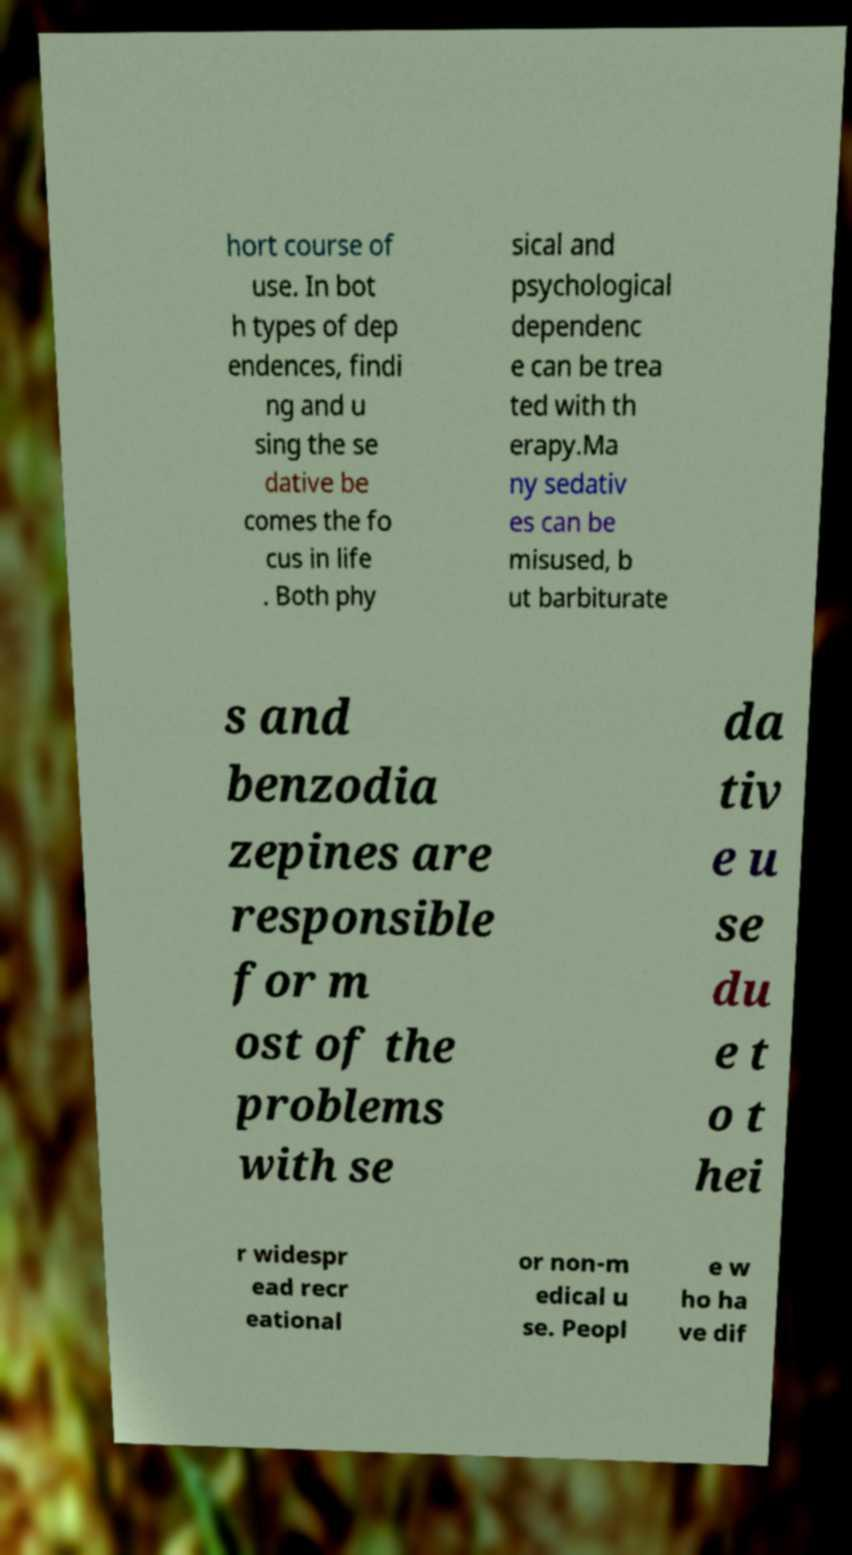Please read and relay the text visible in this image. What does it say? hort course of use. In bot h types of dep endences, findi ng and u sing the se dative be comes the fo cus in life . Both phy sical and psychological dependenc e can be trea ted with th erapy.Ma ny sedativ es can be misused, b ut barbiturate s and benzodia zepines are responsible for m ost of the problems with se da tiv e u se du e t o t hei r widespr ead recr eational or non-m edical u se. Peopl e w ho ha ve dif 